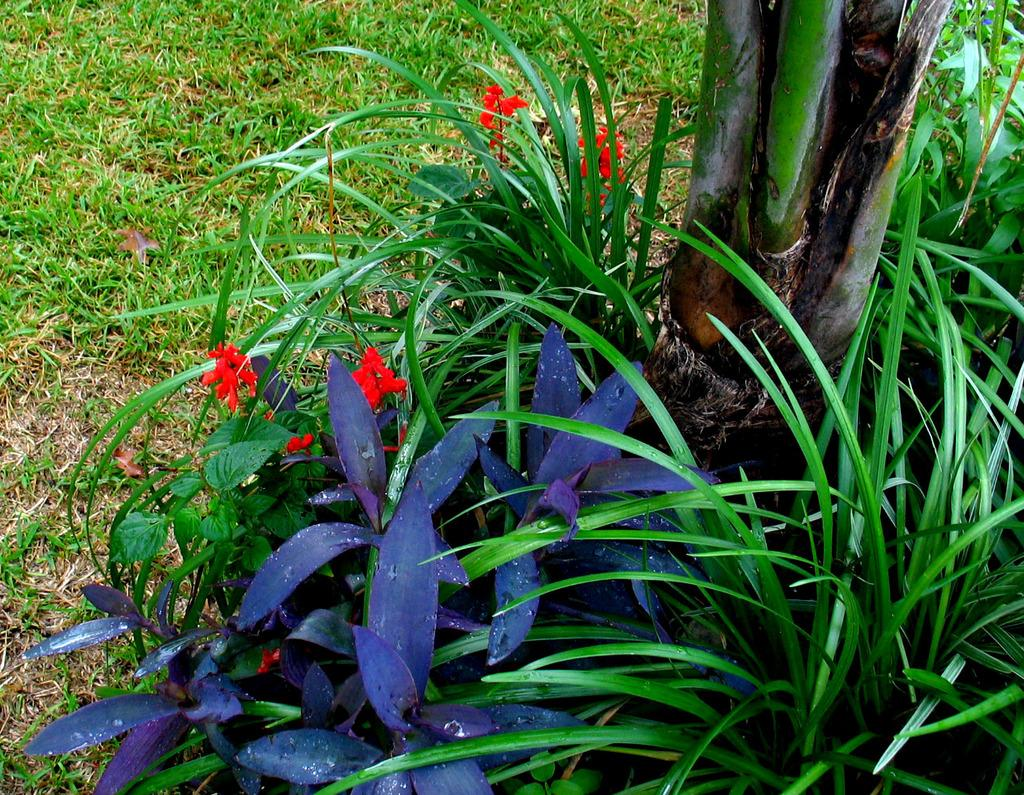What types of vegetation can be seen in the foreground of the image? There are plants and flowers in the foreground of the image. Can you describe the vegetation in the background of the image? There is grass visible in the background of the image. What is located on the right side of the image? There is a tree on the right side of the image. What type of plantation is visible in the image? There is no plantation present in the image; it features plants, flowers, grass, and a tree. What property is being depicted in the image? The image does not depict a specific property; it focuses on the vegetation and natural elements. 